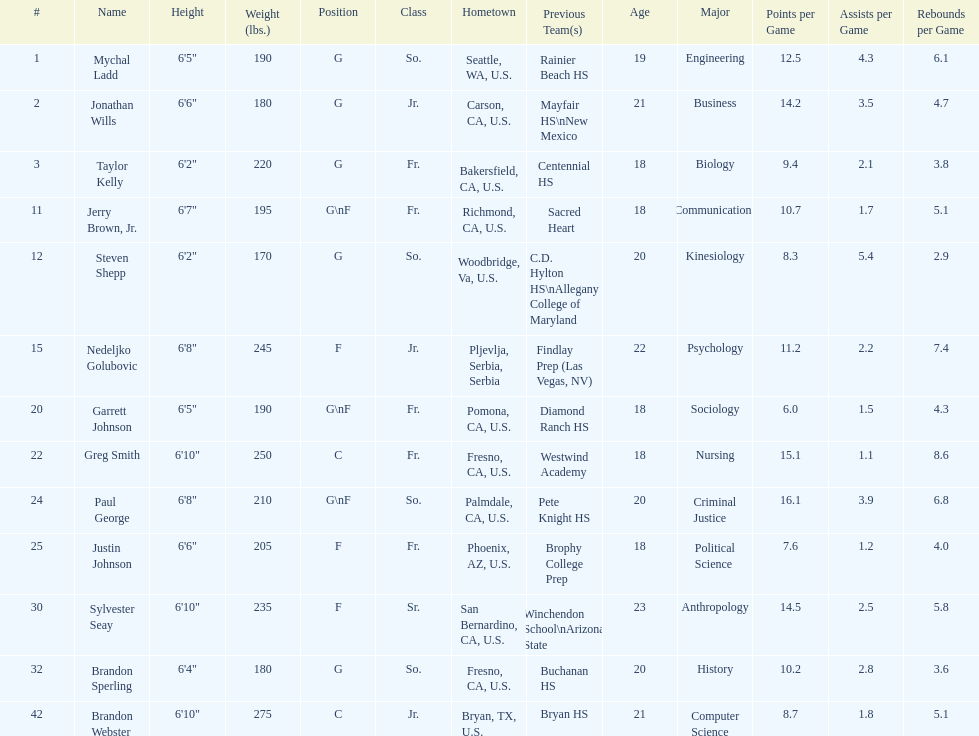Can you parse all the data within this table? {'header': ['#', 'Name', 'Height', 'Weight (lbs.)', 'Position', 'Class', 'Hometown', 'Previous Team(s)', 'Age', 'Major', 'Points per Game', 'Assists per Game', 'Rebounds per Game'], 'rows': [['1', 'Mychal Ladd', '6\'5"', '190', 'G', 'So.', 'Seattle, WA, U.S.', 'Rainier Beach HS', '19', 'Engineering', '12.5', '4.3', '6.1'], ['2', 'Jonathan Wills', '6\'6"', '180', 'G', 'Jr.', 'Carson, CA, U.S.', 'Mayfair HS\\nNew Mexico', '21', 'Business', '14.2', '3.5', '4.7'], ['3', 'Taylor Kelly', '6\'2"', '220', 'G', 'Fr.', 'Bakersfield, CA, U.S.', 'Centennial HS', '18', 'Biology', '9.4', '2.1', '3.8'], ['11', 'Jerry Brown, Jr.', '6\'7"', '195', 'G\\nF', 'Fr.', 'Richmond, CA, U.S.', 'Sacred Heart', '18', 'Communications', '10.7', '1.7', '5.1'], ['12', 'Steven Shepp', '6\'2"', '170', 'G', 'So.', 'Woodbridge, Va, U.S.', 'C.D. Hylton HS\\nAllegany College of Maryland', '20', 'Kinesiology', '8.3', '5.4', '2.9'], ['15', 'Nedeljko Golubovic', '6\'8"', '245', 'F', 'Jr.', 'Pljevlja, Serbia, Serbia', 'Findlay Prep (Las Vegas, NV)', '22', 'Psychology', '11.2', '2.2', '7.4'], ['20', 'Garrett Johnson', '6\'5"', '190', 'G\\nF', 'Fr.', 'Pomona, CA, U.S.', 'Diamond Ranch HS', '18', 'Sociology', '6.0', '1.5', '4.3'], ['22', 'Greg Smith', '6\'10"', '250', 'C', 'Fr.', 'Fresno, CA, U.S.', 'Westwind Academy', '18', 'Nursing', '15.1', '1.1', '8.6'], ['24', 'Paul George', '6\'8"', '210', 'G\\nF', 'So.', 'Palmdale, CA, U.S.', 'Pete Knight HS', '20', 'Criminal Justice', '16.1', '3.9', '6.8'], ['25', 'Justin Johnson', '6\'6"', '205', 'F', 'Fr.', 'Phoenix, AZ, U.S.', 'Brophy College Prep', '18', 'Political Science', '7.6', '1.2', '4.0'], ['30', 'Sylvester Seay', '6\'10"', '235', 'F', 'Sr.', 'San Bernardino, CA, U.S.', 'Winchendon School\\nArizona State', '23', 'Anthropology', '14.5', '2.5', '5.8'], ['32', 'Brandon Sperling', '6\'4"', '180', 'G', 'So.', 'Fresno, CA, U.S.', 'Buchanan HS', '20', 'History', '10.2', '2.8', '3.6'], ['42', 'Brandon Webster', '6\'10"', '275', 'C', 'Jr.', 'Bryan, TX, U.S.', 'Bryan HS', '21', 'Computer Science', '8.7', '1.8', '5.1']]} Who is the only player not from the u. s.? Nedeljko Golubovic. 